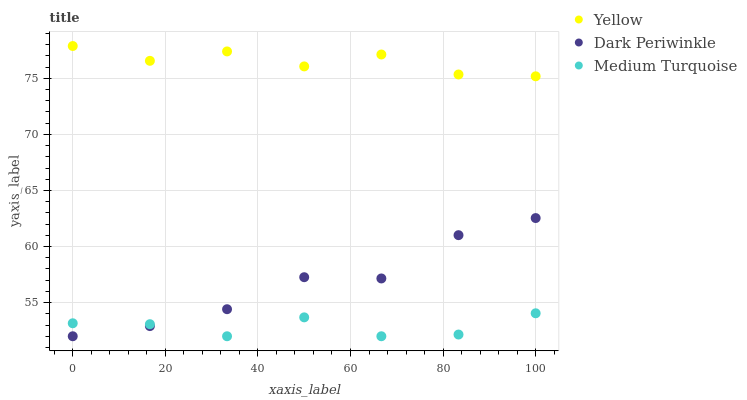Does Medium Turquoise have the minimum area under the curve?
Answer yes or no. Yes. Does Yellow have the maximum area under the curve?
Answer yes or no. Yes. Does Dark Periwinkle have the minimum area under the curve?
Answer yes or no. No. Does Dark Periwinkle have the maximum area under the curve?
Answer yes or no. No. Is Medium Turquoise the smoothest?
Answer yes or no. Yes. Is Dark Periwinkle the roughest?
Answer yes or no. Yes. Is Yellow the smoothest?
Answer yes or no. No. Is Yellow the roughest?
Answer yes or no. No. Does Medium Turquoise have the lowest value?
Answer yes or no. Yes. Does Yellow have the lowest value?
Answer yes or no. No. Does Yellow have the highest value?
Answer yes or no. Yes. Does Dark Periwinkle have the highest value?
Answer yes or no. No. Is Medium Turquoise less than Yellow?
Answer yes or no. Yes. Is Yellow greater than Medium Turquoise?
Answer yes or no. Yes. Does Medium Turquoise intersect Dark Periwinkle?
Answer yes or no. Yes. Is Medium Turquoise less than Dark Periwinkle?
Answer yes or no. No. Is Medium Turquoise greater than Dark Periwinkle?
Answer yes or no. No. Does Medium Turquoise intersect Yellow?
Answer yes or no. No. 